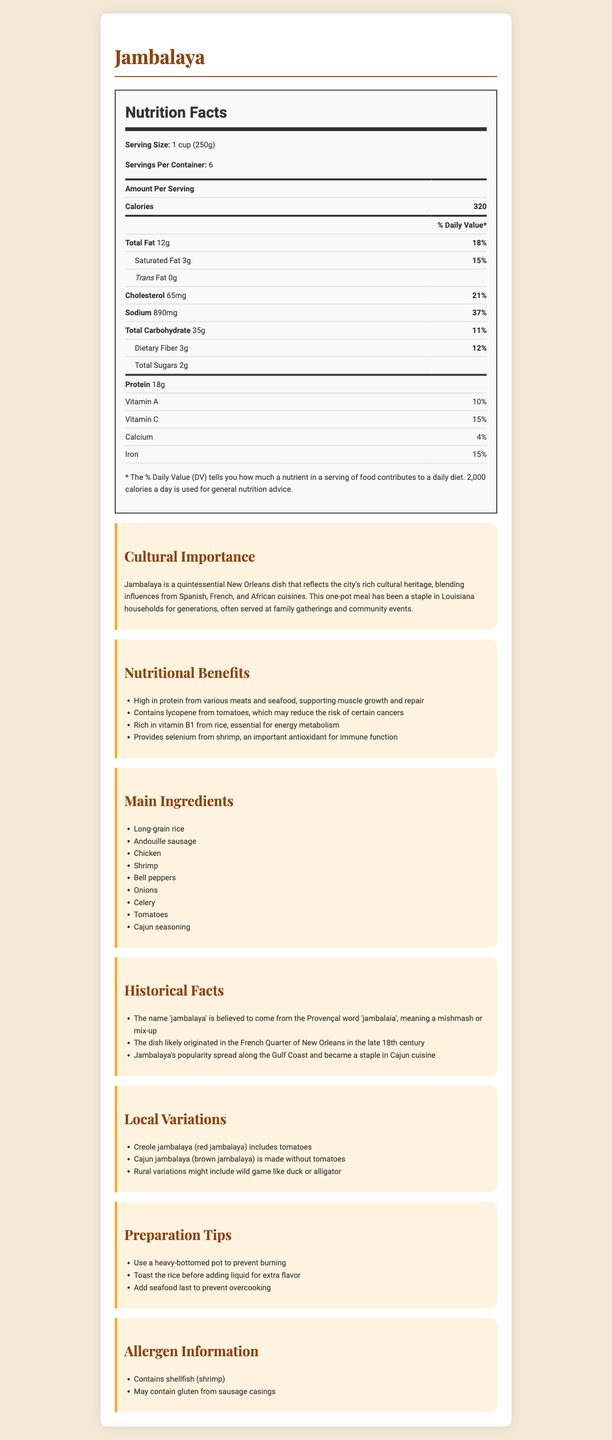What is the serving size for Jambalaya? The serving size is mentioned at the beginning of the nutrition facts section as "1 cup (250g)".
Answer: 1 cup (250g) How many servings are there per container of Jambalaya? The document specifies that there are 6 servings per container.
Answer: 6 What percentage of the daily value of Vitamin C does one serving of Jambalaya provide? The document lists that one serving of Jambalaya provides 15% of the daily value of Vitamin C.
Answer: 15% How much cholesterol is in one serving of Jambalaya? The amount of cholesterol in one serving is stated as 65mg in the nutrition facts.
Answer: 65mg How is Creole jambalaya different from Cajun jambalaya? The document explains that Creole jambalaya includes tomatoes, giving it a red color, whereas Cajun jambalaya is made without tomatoes.
Answer: Creole jambalaya includes tomatoes, while Cajun jambalaya does not. What percentage of the daily value of iron does one serving of Jambalaya provide? The document shows that one serving provides 15% of the daily value of iron.
Answer: 15% What are some of the cultural influences on Jambalaya? A. Spanish and French B. Italian and German C. Chinese and Japanese The document mentions that Jambalaya reflects the city's rich cultural heritage, blending influences from Spanish, French, and African cuisines.
Answer: A. Spanish and French Which local variation of Jambalaya might include wild game like duck or alligator? A. Creole jambalaya B. Cajun jambalaya C. Rural variations The document specifies that rural variations might include wild game like duck or alligator.
Answer: C. Rural variations Does Jambalaya contain any potential allergens? The document lists that Jambalaya contains shellfish (shrimp) and may contain gluten from sausage casings.
Answer: Yes Describe the main idea of the document. The main idea of the document is to offer detailed insight into Jambalaya, covering its nutritional benefits, cultural significance, and practical cooking information.
Answer: The document provides a comprehensive overview of the nutritional facts, cultural importance, historical facts, local variations, preparation tips, and allergen information for the traditional New Orleans dish, Jambalaya. Is andouille sausage a main ingredient in Jambalaya? The document lists andouille sausage as one of the main ingredients in Jambalaya.
Answer: Yes When did Jambalaya likely originate in the French Quarter of New Orleans? The document mentions that Jambalaya likely originated in the French Quarter of New Orleans in the late 18th century.
Answer: In the late 18th century How many total grams of fat are in one serving of Jambalaya? The nutrition facts section states that there are 12 grams of total fat per serving.
Answer: 12g What is the origin of the name 'jambalaya'? The document provides the historical fact that the name 'jambalaya' comes from the Provençal word 'jambalaia'.
Answer: The name 'jambalaya' is believed to come from the Provençal word 'jambalaia', meaning a mishmash or mix-up. How many grams of dietary fiber are in one serving of Jambalaya? The nutrition facts state that one serving contains 3 grams of dietary fiber.
Answer: 3g Does Jambalaya help support muscle growth and repair? One of the nutritional benefits mentioned is that Jambalaya is high in protein from various meats and seafood, supporting muscle growth and repair.
Answer: Yes Can the exact origin of the word 'jambalaya' be determined from the document? The document states a belief about the origin of the word but does not provide conclusive evidence or detail beyond the Provençal association.
Answer: Not enough information 